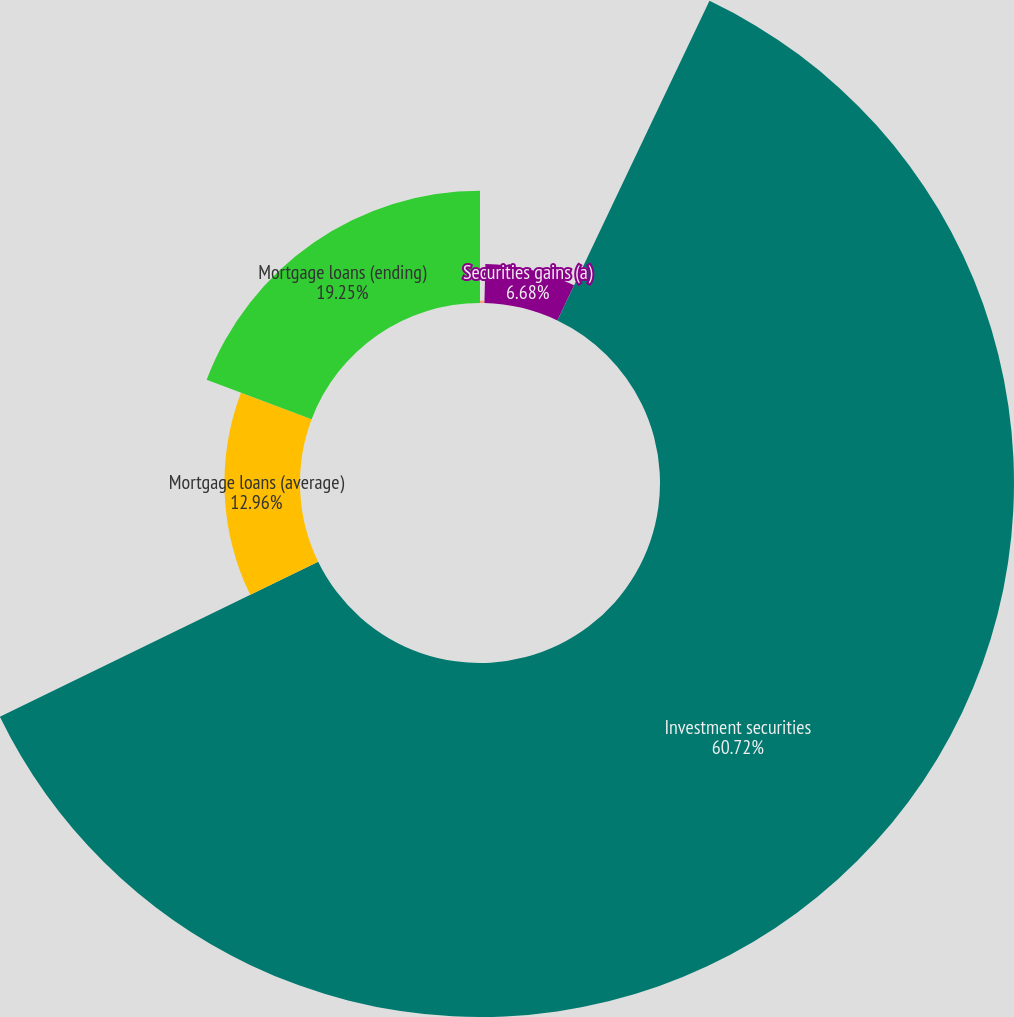Convert chart. <chart><loc_0><loc_0><loc_500><loc_500><pie_chart><fcel>As of or for the year ended<fcel>Securities gains (a)<fcel>Investment securities<fcel>Mortgage loans (average)<fcel>Mortgage loans (ending)<nl><fcel>0.39%<fcel>6.68%<fcel>60.72%<fcel>12.96%<fcel>19.25%<nl></chart> 